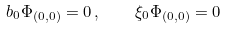<formula> <loc_0><loc_0><loc_500><loc_500>b _ { 0 } \Phi _ { ( 0 , 0 ) } = 0 \, , \quad \xi _ { 0 } \Phi _ { ( 0 , 0 ) } = 0</formula> 